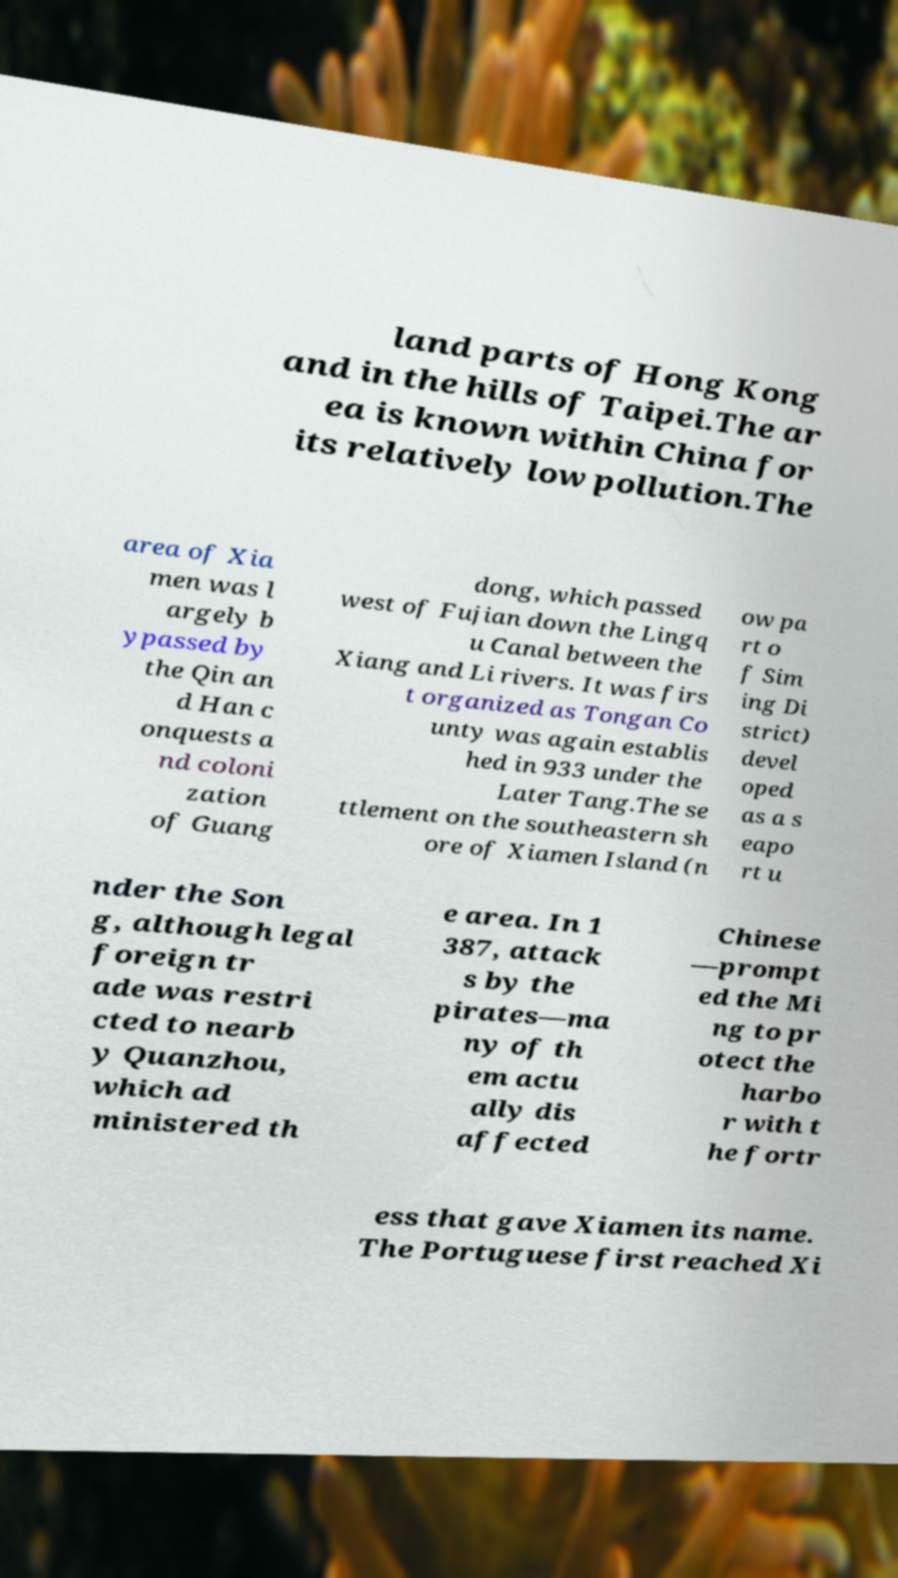Please identify and transcribe the text found in this image. land parts of Hong Kong and in the hills of Taipei.The ar ea is known within China for its relatively low pollution.The area of Xia men was l argely b ypassed by the Qin an d Han c onquests a nd coloni zation of Guang dong, which passed west of Fujian down the Lingq u Canal between the Xiang and Li rivers. It was firs t organized as Tongan Co unty was again establis hed in 933 under the Later Tang.The se ttlement on the southeastern sh ore of Xiamen Island (n ow pa rt o f Sim ing Di strict) devel oped as a s eapo rt u nder the Son g, although legal foreign tr ade was restri cted to nearb y Quanzhou, which ad ministered th e area. In 1 387, attack s by the pirates—ma ny of th em actu ally dis affected Chinese —prompt ed the Mi ng to pr otect the harbo r with t he fortr ess that gave Xiamen its name. The Portuguese first reached Xi 